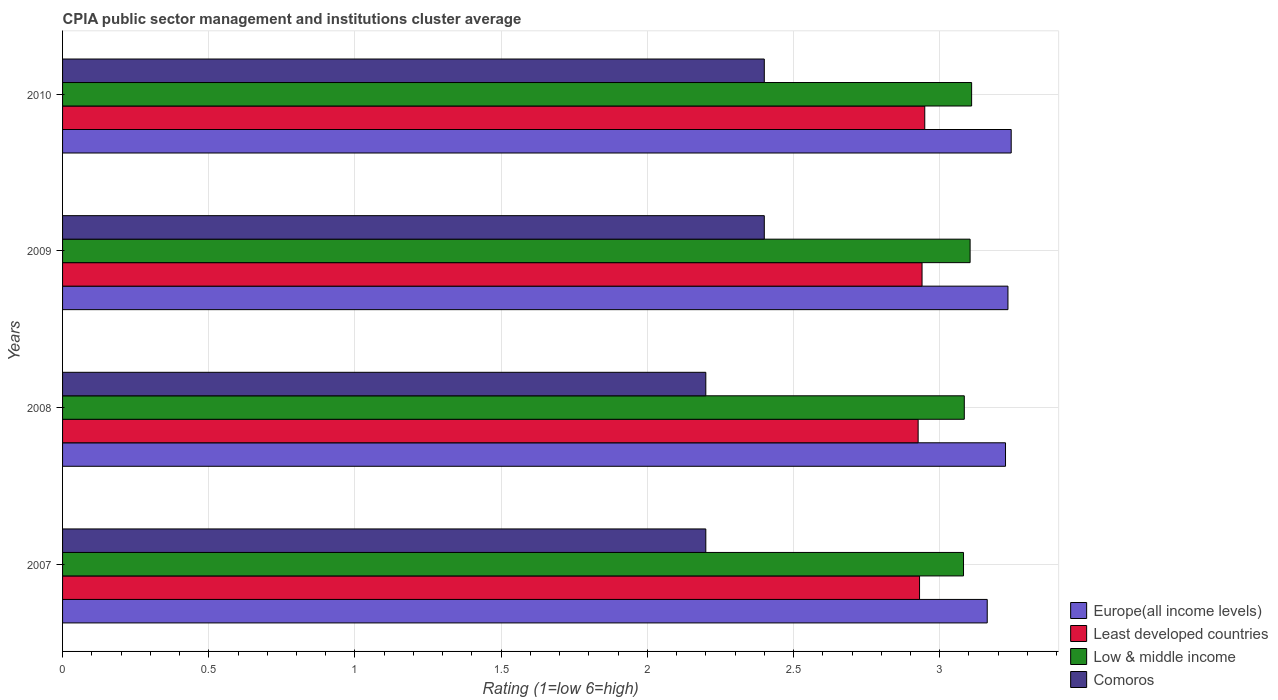How many groups of bars are there?
Offer a very short reply. 4. Are the number of bars on each tick of the Y-axis equal?
Keep it short and to the point. Yes. What is the label of the 4th group of bars from the top?
Ensure brevity in your answer.  2007. What is the CPIA rating in Low & middle income in 2010?
Offer a very short reply. 3.11. Across all years, what is the maximum CPIA rating in Low & middle income?
Give a very brief answer. 3.11. Across all years, what is the minimum CPIA rating in Low & middle income?
Make the answer very short. 3.08. In which year was the CPIA rating in Low & middle income minimum?
Your answer should be very brief. 2007. What is the total CPIA rating in Europe(all income levels) in the graph?
Offer a very short reply. 12.87. What is the difference between the CPIA rating in Low & middle income in 2007 and that in 2010?
Give a very brief answer. -0.03. What is the difference between the CPIA rating in Comoros in 2009 and the CPIA rating in Least developed countries in 2007?
Provide a succinct answer. -0.53. What is the average CPIA rating in Europe(all income levels) per year?
Your answer should be compact. 3.22. In the year 2009, what is the difference between the CPIA rating in Low & middle income and CPIA rating in Europe(all income levels)?
Offer a very short reply. -0.13. What is the ratio of the CPIA rating in Europe(all income levels) in 2008 to that in 2010?
Your answer should be very brief. 0.99. What is the difference between the highest and the second highest CPIA rating in Europe(all income levels)?
Your answer should be compact. 0.01. What is the difference between the highest and the lowest CPIA rating in Europe(all income levels)?
Give a very brief answer. 0.08. What does the 3rd bar from the top in 2010 represents?
Your answer should be very brief. Least developed countries. What does the 4th bar from the bottom in 2008 represents?
Your answer should be compact. Comoros. Is it the case that in every year, the sum of the CPIA rating in Europe(all income levels) and CPIA rating in Comoros is greater than the CPIA rating in Least developed countries?
Offer a terse response. Yes. How many bars are there?
Your answer should be compact. 16. How many years are there in the graph?
Offer a terse response. 4. Does the graph contain any zero values?
Your answer should be very brief. No. Does the graph contain grids?
Ensure brevity in your answer.  Yes. Where does the legend appear in the graph?
Ensure brevity in your answer.  Bottom right. What is the title of the graph?
Offer a very short reply. CPIA public sector management and institutions cluster average. What is the label or title of the X-axis?
Offer a very short reply. Rating (1=low 6=high). What is the label or title of the Y-axis?
Ensure brevity in your answer.  Years. What is the Rating (1=low 6=high) of Europe(all income levels) in 2007?
Ensure brevity in your answer.  3.16. What is the Rating (1=low 6=high) of Least developed countries in 2007?
Provide a short and direct response. 2.93. What is the Rating (1=low 6=high) of Low & middle income in 2007?
Offer a very short reply. 3.08. What is the Rating (1=low 6=high) in Europe(all income levels) in 2008?
Provide a succinct answer. 3.23. What is the Rating (1=low 6=high) in Least developed countries in 2008?
Offer a terse response. 2.93. What is the Rating (1=low 6=high) of Low & middle income in 2008?
Make the answer very short. 3.08. What is the Rating (1=low 6=high) of Europe(all income levels) in 2009?
Ensure brevity in your answer.  3.23. What is the Rating (1=low 6=high) of Least developed countries in 2009?
Your answer should be very brief. 2.94. What is the Rating (1=low 6=high) of Low & middle income in 2009?
Your response must be concise. 3.1. What is the Rating (1=low 6=high) of Comoros in 2009?
Provide a short and direct response. 2.4. What is the Rating (1=low 6=high) in Europe(all income levels) in 2010?
Make the answer very short. 3.24. What is the Rating (1=low 6=high) in Least developed countries in 2010?
Offer a terse response. 2.95. What is the Rating (1=low 6=high) of Low & middle income in 2010?
Ensure brevity in your answer.  3.11. Across all years, what is the maximum Rating (1=low 6=high) of Europe(all income levels)?
Make the answer very short. 3.24. Across all years, what is the maximum Rating (1=low 6=high) in Least developed countries?
Offer a terse response. 2.95. Across all years, what is the maximum Rating (1=low 6=high) of Low & middle income?
Provide a succinct answer. 3.11. Across all years, what is the maximum Rating (1=low 6=high) of Comoros?
Provide a short and direct response. 2.4. Across all years, what is the minimum Rating (1=low 6=high) in Europe(all income levels)?
Give a very brief answer. 3.16. Across all years, what is the minimum Rating (1=low 6=high) of Least developed countries?
Ensure brevity in your answer.  2.93. Across all years, what is the minimum Rating (1=low 6=high) of Low & middle income?
Your response must be concise. 3.08. What is the total Rating (1=low 6=high) in Europe(all income levels) in the graph?
Provide a succinct answer. 12.87. What is the total Rating (1=low 6=high) in Least developed countries in the graph?
Your answer should be very brief. 11.75. What is the total Rating (1=low 6=high) in Low & middle income in the graph?
Ensure brevity in your answer.  12.38. What is the total Rating (1=low 6=high) of Comoros in the graph?
Provide a short and direct response. 9.2. What is the difference between the Rating (1=low 6=high) of Europe(all income levels) in 2007 and that in 2008?
Make the answer very short. -0.06. What is the difference between the Rating (1=low 6=high) of Least developed countries in 2007 and that in 2008?
Keep it short and to the point. 0. What is the difference between the Rating (1=low 6=high) of Low & middle income in 2007 and that in 2008?
Ensure brevity in your answer.  -0. What is the difference between the Rating (1=low 6=high) of Comoros in 2007 and that in 2008?
Offer a terse response. 0. What is the difference between the Rating (1=low 6=high) in Europe(all income levels) in 2007 and that in 2009?
Offer a terse response. -0.07. What is the difference between the Rating (1=low 6=high) of Least developed countries in 2007 and that in 2009?
Offer a very short reply. -0.01. What is the difference between the Rating (1=low 6=high) in Low & middle income in 2007 and that in 2009?
Offer a very short reply. -0.02. What is the difference between the Rating (1=low 6=high) of Europe(all income levels) in 2007 and that in 2010?
Offer a terse response. -0.08. What is the difference between the Rating (1=low 6=high) in Least developed countries in 2007 and that in 2010?
Give a very brief answer. -0.02. What is the difference between the Rating (1=low 6=high) of Low & middle income in 2007 and that in 2010?
Give a very brief answer. -0.03. What is the difference between the Rating (1=low 6=high) of Europe(all income levels) in 2008 and that in 2009?
Offer a terse response. -0.01. What is the difference between the Rating (1=low 6=high) in Least developed countries in 2008 and that in 2009?
Your response must be concise. -0.01. What is the difference between the Rating (1=low 6=high) in Low & middle income in 2008 and that in 2009?
Your answer should be very brief. -0.02. What is the difference between the Rating (1=low 6=high) in Comoros in 2008 and that in 2009?
Keep it short and to the point. -0.2. What is the difference between the Rating (1=low 6=high) of Europe(all income levels) in 2008 and that in 2010?
Ensure brevity in your answer.  -0.02. What is the difference between the Rating (1=low 6=high) in Least developed countries in 2008 and that in 2010?
Your response must be concise. -0.02. What is the difference between the Rating (1=low 6=high) of Low & middle income in 2008 and that in 2010?
Provide a succinct answer. -0.03. What is the difference between the Rating (1=low 6=high) in Comoros in 2008 and that in 2010?
Provide a succinct answer. -0.2. What is the difference between the Rating (1=low 6=high) in Europe(all income levels) in 2009 and that in 2010?
Provide a succinct answer. -0.01. What is the difference between the Rating (1=low 6=high) in Least developed countries in 2009 and that in 2010?
Offer a very short reply. -0.01. What is the difference between the Rating (1=low 6=high) of Low & middle income in 2009 and that in 2010?
Ensure brevity in your answer.  -0.01. What is the difference between the Rating (1=low 6=high) in Europe(all income levels) in 2007 and the Rating (1=low 6=high) in Least developed countries in 2008?
Offer a very short reply. 0.24. What is the difference between the Rating (1=low 6=high) of Europe(all income levels) in 2007 and the Rating (1=low 6=high) of Low & middle income in 2008?
Provide a short and direct response. 0.08. What is the difference between the Rating (1=low 6=high) in Europe(all income levels) in 2007 and the Rating (1=low 6=high) in Comoros in 2008?
Your response must be concise. 0.96. What is the difference between the Rating (1=low 6=high) of Least developed countries in 2007 and the Rating (1=low 6=high) of Low & middle income in 2008?
Your answer should be very brief. -0.15. What is the difference between the Rating (1=low 6=high) of Least developed countries in 2007 and the Rating (1=low 6=high) of Comoros in 2008?
Your response must be concise. 0.73. What is the difference between the Rating (1=low 6=high) of Low & middle income in 2007 and the Rating (1=low 6=high) of Comoros in 2008?
Provide a short and direct response. 0.88. What is the difference between the Rating (1=low 6=high) in Europe(all income levels) in 2007 and the Rating (1=low 6=high) in Least developed countries in 2009?
Keep it short and to the point. 0.22. What is the difference between the Rating (1=low 6=high) of Europe(all income levels) in 2007 and the Rating (1=low 6=high) of Low & middle income in 2009?
Provide a short and direct response. 0.06. What is the difference between the Rating (1=low 6=high) in Europe(all income levels) in 2007 and the Rating (1=low 6=high) in Comoros in 2009?
Your answer should be very brief. 0.76. What is the difference between the Rating (1=low 6=high) of Least developed countries in 2007 and the Rating (1=low 6=high) of Low & middle income in 2009?
Keep it short and to the point. -0.17. What is the difference between the Rating (1=low 6=high) in Least developed countries in 2007 and the Rating (1=low 6=high) in Comoros in 2009?
Give a very brief answer. 0.53. What is the difference between the Rating (1=low 6=high) in Low & middle income in 2007 and the Rating (1=low 6=high) in Comoros in 2009?
Your response must be concise. 0.68. What is the difference between the Rating (1=low 6=high) in Europe(all income levels) in 2007 and the Rating (1=low 6=high) in Least developed countries in 2010?
Give a very brief answer. 0.21. What is the difference between the Rating (1=low 6=high) in Europe(all income levels) in 2007 and the Rating (1=low 6=high) in Low & middle income in 2010?
Your answer should be compact. 0.05. What is the difference between the Rating (1=low 6=high) in Europe(all income levels) in 2007 and the Rating (1=low 6=high) in Comoros in 2010?
Offer a terse response. 0.76. What is the difference between the Rating (1=low 6=high) in Least developed countries in 2007 and the Rating (1=low 6=high) in Low & middle income in 2010?
Offer a very short reply. -0.18. What is the difference between the Rating (1=low 6=high) in Least developed countries in 2007 and the Rating (1=low 6=high) in Comoros in 2010?
Your answer should be compact. 0.53. What is the difference between the Rating (1=low 6=high) in Low & middle income in 2007 and the Rating (1=low 6=high) in Comoros in 2010?
Provide a succinct answer. 0.68. What is the difference between the Rating (1=low 6=high) in Europe(all income levels) in 2008 and the Rating (1=low 6=high) in Least developed countries in 2009?
Ensure brevity in your answer.  0.29. What is the difference between the Rating (1=low 6=high) in Europe(all income levels) in 2008 and the Rating (1=low 6=high) in Low & middle income in 2009?
Your answer should be very brief. 0.12. What is the difference between the Rating (1=low 6=high) of Europe(all income levels) in 2008 and the Rating (1=low 6=high) of Comoros in 2009?
Keep it short and to the point. 0.82. What is the difference between the Rating (1=low 6=high) in Least developed countries in 2008 and the Rating (1=low 6=high) in Low & middle income in 2009?
Offer a terse response. -0.18. What is the difference between the Rating (1=low 6=high) of Least developed countries in 2008 and the Rating (1=low 6=high) of Comoros in 2009?
Ensure brevity in your answer.  0.53. What is the difference between the Rating (1=low 6=high) in Low & middle income in 2008 and the Rating (1=low 6=high) in Comoros in 2009?
Give a very brief answer. 0.68. What is the difference between the Rating (1=low 6=high) in Europe(all income levels) in 2008 and the Rating (1=low 6=high) in Least developed countries in 2010?
Provide a succinct answer. 0.28. What is the difference between the Rating (1=low 6=high) of Europe(all income levels) in 2008 and the Rating (1=low 6=high) of Low & middle income in 2010?
Make the answer very short. 0.12. What is the difference between the Rating (1=low 6=high) in Europe(all income levels) in 2008 and the Rating (1=low 6=high) in Comoros in 2010?
Provide a short and direct response. 0.82. What is the difference between the Rating (1=low 6=high) in Least developed countries in 2008 and the Rating (1=low 6=high) in Low & middle income in 2010?
Make the answer very short. -0.18. What is the difference between the Rating (1=low 6=high) in Least developed countries in 2008 and the Rating (1=low 6=high) in Comoros in 2010?
Your answer should be compact. 0.53. What is the difference between the Rating (1=low 6=high) of Low & middle income in 2008 and the Rating (1=low 6=high) of Comoros in 2010?
Make the answer very short. 0.68. What is the difference between the Rating (1=low 6=high) of Europe(all income levels) in 2009 and the Rating (1=low 6=high) of Least developed countries in 2010?
Make the answer very short. 0.28. What is the difference between the Rating (1=low 6=high) in Europe(all income levels) in 2009 and the Rating (1=low 6=high) in Low & middle income in 2010?
Offer a terse response. 0.12. What is the difference between the Rating (1=low 6=high) of Europe(all income levels) in 2009 and the Rating (1=low 6=high) of Comoros in 2010?
Offer a very short reply. 0.83. What is the difference between the Rating (1=low 6=high) in Least developed countries in 2009 and the Rating (1=low 6=high) in Low & middle income in 2010?
Provide a succinct answer. -0.17. What is the difference between the Rating (1=low 6=high) of Least developed countries in 2009 and the Rating (1=low 6=high) of Comoros in 2010?
Offer a very short reply. 0.54. What is the difference between the Rating (1=low 6=high) of Low & middle income in 2009 and the Rating (1=low 6=high) of Comoros in 2010?
Offer a terse response. 0.7. What is the average Rating (1=low 6=high) in Europe(all income levels) per year?
Keep it short and to the point. 3.22. What is the average Rating (1=low 6=high) in Least developed countries per year?
Ensure brevity in your answer.  2.94. What is the average Rating (1=low 6=high) in Low & middle income per year?
Your answer should be compact. 3.09. What is the average Rating (1=low 6=high) in Comoros per year?
Offer a terse response. 2.3. In the year 2007, what is the difference between the Rating (1=low 6=high) of Europe(all income levels) and Rating (1=low 6=high) of Least developed countries?
Your answer should be compact. 0.23. In the year 2007, what is the difference between the Rating (1=low 6=high) of Europe(all income levels) and Rating (1=low 6=high) of Low & middle income?
Keep it short and to the point. 0.08. In the year 2007, what is the difference between the Rating (1=low 6=high) of Europe(all income levels) and Rating (1=low 6=high) of Comoros?
Provide a short and direct response. 0.96. In the year 2007, what is the difference between the Rating (1=low 6=high) of Least developed countries and Rating (1=low 6=high) of Low & middle income?
Offer a terse response. -0.15. In the year 2007, what is the difference between the Rating (1=low 6=high) of Least developed countries and Rating (1=low 6=high) of Comoros?
Ensure brevity in your answer.  0.73. In the year 2007, what is the difference between the Rating (1=low 6=high) in Low & middle income and Rating (1=low 6=high) in Comoros?
Offer a terse response. 0.88. In the year 2008, what is the difference between the Rating (1=low 6=high) of Europe(all income levels) and Rating (1=low 6=high) of Least developed countries?
Make the answer very short. 0.3. In the year 2008, what is the difference between the Rating (1=low 6=high) of Europe(all income levels) and Rating (1=low 6=high) of Low & middle income?
Make the answer very short. 0.14. In the year 2008, what is the difference between the Rating (1=low 6=high) of Europe(all income levels) and Rating (1=low 6=high) of Comoros?
Provide a short and direct response. 1.02. In the year 2008, what is the difference between the Rating (1=low 6=high) in Least developed countries and Rating (1=low 6=high) in Low & middle income?
Provide a short and direct response. -0.16. In the year 2008, what is the difference between the Rating (1=low 6=high) of Least developed countries and Rating (1=low 6=high) of Comoros?
Ensure brevity in your answer.  0.73. In the year 2008, what is the difference between the Rating (1=low 6=high) of Low & middle income and Rating (1=low 6=high) of Comoros?
Offer a terse response. 0.88. In the year 2009, what is the difference between the Rating (1=low 6=high) in Europe(all income levels) and Rating (1=low 6=high) in Least developed countries?
Make the answer very short. 0.29. In the year 2009, what is the difference between the Rating (1=low 6=high) of Europe(all income levels) and Rating (1=low 6=high) of Low & middle income?
Keep it short and to the point. 0.13. In the year 2009, what is the difference between the Rating (1=low 6=high) in Europe(all income levels) and Rating (1=low 6=high) in Comoros?
Your answer should be very brief. 0.83. In the year 2009, what is the difference between the Rating (1=low 6=high) of Least developed countries and Rating (1=low 6=high) of Low & middle income?
Offer a very short reply. -0.16. In the year 2009, what is the difference between the Rating (1=low 6=high) of Least developed countries and Rating (1=low 6=high) of Comoros?
Keep it short and to the point. 0.54. In the year 2009, what is the difference between the Rating (1=low 6=high) in Low & middle income and Rating (1=low 6=high) in Comoros?
Ensure brevity in your answer.  0.7. In the year 2010, what is the difference between the Rating (1=low 6=high) of Europe(all income levels) and Rating (1=low 6=high) of Least developed countries?
Keep it short and to the point. 0.3. In the year 2010, what is the difference between the Rating (1=low 6=high) in Europe(all income levels) and Rating (1=low 6=high) in Low & middle income?
Offer a terse response. 0.14. In the year 2010, what is the difference between the Rating (1=low 6=high) of Europe(all income levels) and Rating (1=low 6=high) of Comoros?
Give a very brief answer. 0.84. In the year 2010, what is the difference between the Rating (1=low 6=high) in Least developed countries and Rating (1=low 6=high) in Low & middle income?
Ensure brevity in your answer.  -0.16. In the year 2010, what is the difference between the Rating (1=low 6=high) in Least developed countries and Rating (1=low 6=high) in Comoros?
Provide a succinct answer. 0.55. In the year 2010, what is the difference between the Rating (1=low 6=high) of Low & middle income and Rating (1=low 6=high) of Comoros?
Your response must be concise. 0.71. What is the ratio of the Rating (1=low 6=high) of Europe(all income levels) in 2007 to that in 2008?
Provide a succinct answer. 0.98. What is the ratio of the Rating (1=low 6=high) in Least developed countries in 2007 to that in 2008?
Keep it short and to the point. 1. What is the ratio of the Rating (1=low 6=high) in Europe(all income levels) in 2007 to that in 2009?
Keep it short and to the point. 0.98. What is the ratio of the Rating (1=low 6=high) of Least developed countries in 2007 to that in 2009?
Your answer should be compact. 1. What is the ratio of the Rating (1=low 6=high) of Low & middle income in 2007 to that in 2009?
Your response must be concise. 0.99. What is the ratio of the Rating (1=low 6=high) of Europe(all income levels) in 2007 to that in 2010?
Offer a very short reply. 0.97. What is the ratio of the Rating (1=low 6=high) in Least developed countries in 2007 to that in 2010?
Your response must be concise. 0.99. What is the ratio of the Rating (1=low 6=high) in Low & middle income in 2007 to that in 2010?
Ensure brevity in your answer.  0.99. What is the ratio of the Rating (1=low 6=high) of Comoros in 2007 to that in 2010?
Provide a succinct answer. 0.92. What is the ratio of the Rating (1=low 6=high) in Low & middle income in 2008 to that in 2009?
Offer a very short reply. 0.99. What is the ratio of the Rating (1=low 6=high) in Europe(all income levels) in 2008 to that in 2010?
Ensure brevity in your answer.  0.99. What is the ratio of the Rating (1=low 6=high) of Low & middle income in 2008 to that in 2010?
Provide a succinct answer. 0.99. What is the ratio of the Rating (1=low 6=high) of Comoros in 2008 to that in 2010?
Make the answer very short. 0.92. What is the ratio of the Rating (1=low 6=high) in Europe(all income levels) in 2009 to that in 2010?
Offer a very short reply. 1. What is the ratio of the Rating (1=low 6=high) in Least developed countries in 2009 to that in 2010?
Your answer should be compact. 1. What is the difference between the highest and the second highest Rating (1=low 6=high) in Europe(all income levels)?
Offer a terse response. 0.01. What is the difference between the highest and the second highest Rating (1=low 6=high) of Least developed countries?
Ensure brevity in your answer.  0.01. What is the difference between the highest and the second highest Rating (1=low 6=high) in Low & middle income?
Offer a very short reply. 0.01. What is the difference between the highest and the lowest Rating (1=low 6=high) in Europe(all income levels)?
Give a very brief answer. 0.08. What is the difference between the highest and the lowest Rating (1=low 6=high) in Least developed countries?
Keep it short and to the point. 0.02. What is the difference between the highest and the lowest Rating (1=low 6=high) of Low & middle income?
Ensure brevity in your answer.  0.03. 